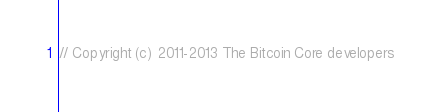Convert code to text. <code><loc_0><loc_0><loc_500><loc_500><_ObjectiveC_>// Copyright (c) 2011-2013 The Bitcoin Core developers</code> 